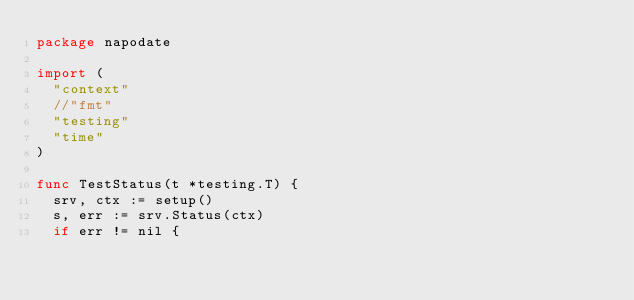<code> <loc_0><loc_0><loc_500><loc_500><_Go_>package napodate

import (
	"context"
	//"fmt"
	"testing"
	"time"
)

func TestStatus(t *testing.T) {
	srv, ctx := setup()
	s, err := srv.Status(ctx)
	if err != nil {</code> 